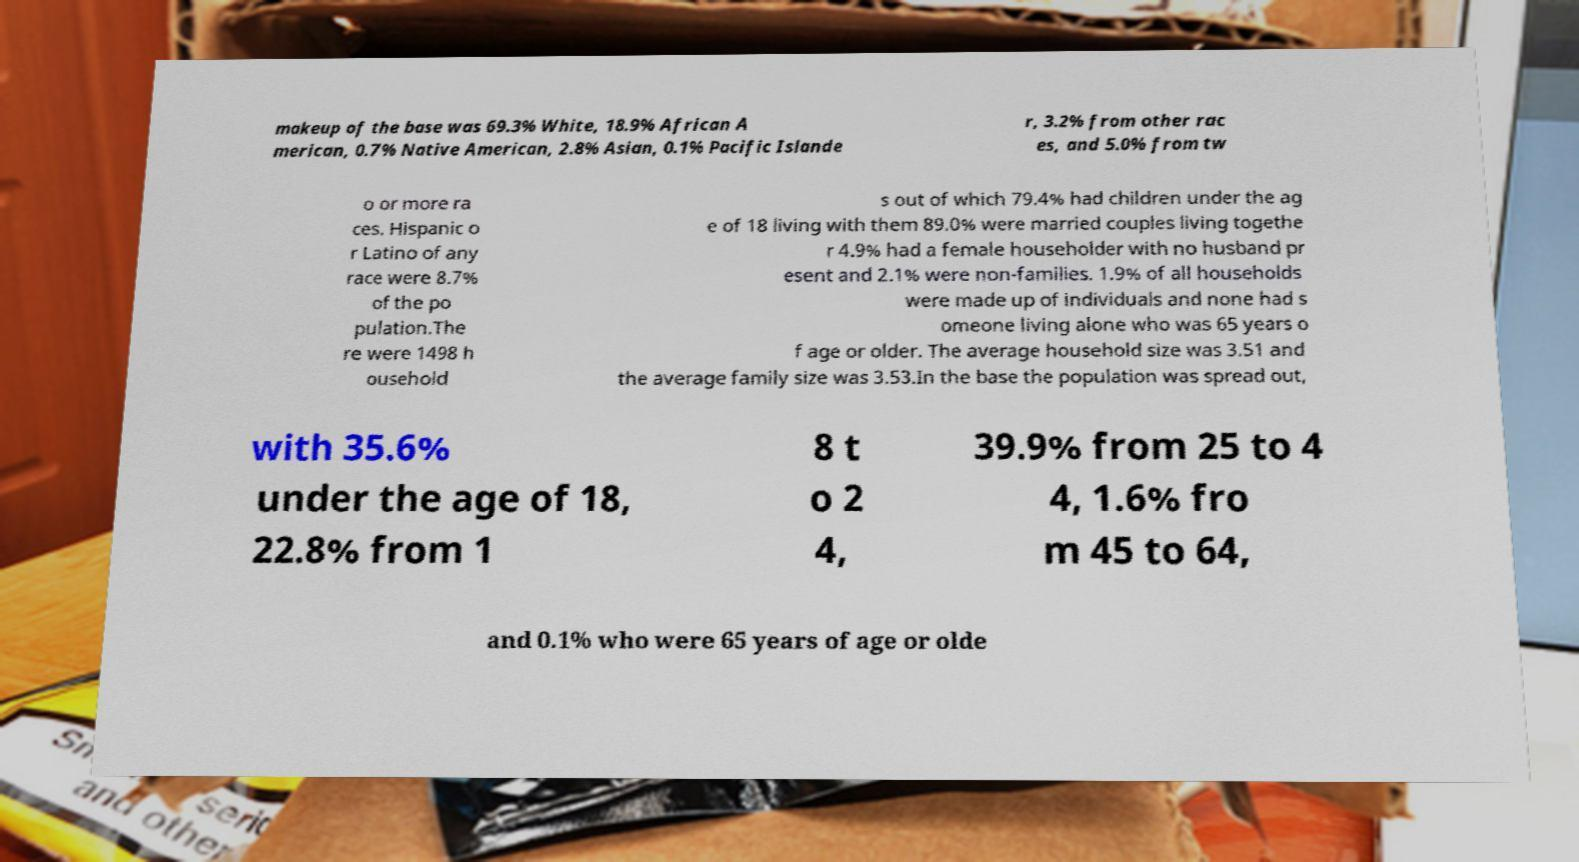What messages or text are displayed in this image? I need them in a readable, typed format. makeup of the base was 69.3% White, 18.9% African A merican, 0.7% Native American, 2.8% Asian, 0.1% Pacific Islande r, 3.2% from other rac es, and 5.0% from tw o or more ra ces. Hispanic o r Latino of any race were 8.7% of the po pulation.The re were 1498 h ousehold s out of which 79.4% had children under the ag e of 18 living with them 89.0% were married couples living togethe r 4.9% had a female householder with no husband pr esent and 2.1% were non-families. 1.9% of all households were made up of individuals and none had s omeone living alone who was 65 years o f age or older. The average household size was 3.51 and the average family size was 3.53.In the base the population was spread out, with 35.6% under the age of 18, 22.8% from 1 8 t o 2 4, 39.9% from 25 to 4 4, 1.6% fro m 45 to 64, and 0.1% who were 65 years of age or olde 